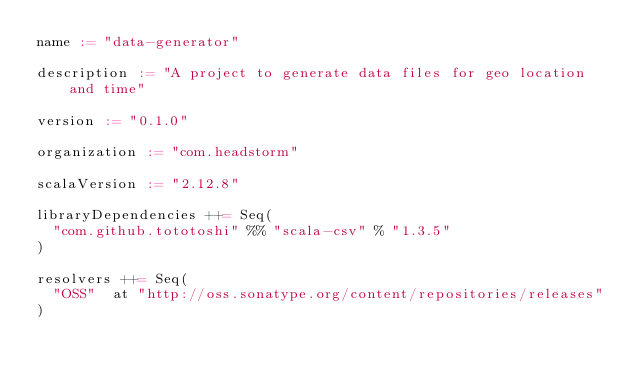<code> <loc_0><loc_0><loc_500><loc_500><_Scala_>name := "data-generator"

description := "A project to generate data files for geo location and time"

version := "0.1.0"

organization := "com.headstorm"

scalaVersion := "2.12.8"

libraryDependencies ++= Seq(
  "com.github.tototoshi" %% "scala-csv" % "1.3.5"
)

resolvers ++= Seq(
  "OSS"  at "http://oss.sonatype.org/content/repositories/releases"
)</code> 